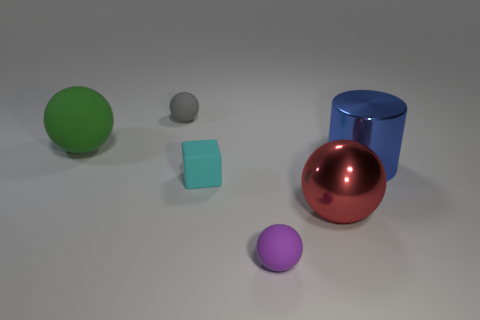Is there a large blue cylinder made of the same material as the red sphere?
Provide a short and direct response. Yes. The small rubber thing that is behind the large sphere on the left side of the small gray thing that is left of the large blue metallic cylinder is what color?
Offer a very short reply. Gray. What number of purple objects are either large metallic balls or shiny objects?
Offer a terse response. 0. How many large red shiny things have the same shape as the tiny purple matte thing?
Offer a very short reply. 1. What shape is the red metal thing that is the same size as the blue object?
Your answer should be very brief. Sphere. There is a large red sphere; are there any large metallic cylinders behind it?
Provide a succinct answer. Yes. Is there a rubber ball on the left side of the small rubber ball that is in front of the gray ball?
Make the answer very short. Yes. Is the number of objects in front of the red shiny thing less than the number of small rubber things to the left of the green sphere?
Offer a terse response. No. There is a blue object; what shape is it?
Make the answer very short. Cylinder. There is a tiny sphere that is to the left of the cyan matte block; what is its material?
Make the answer very short. Rubber. 